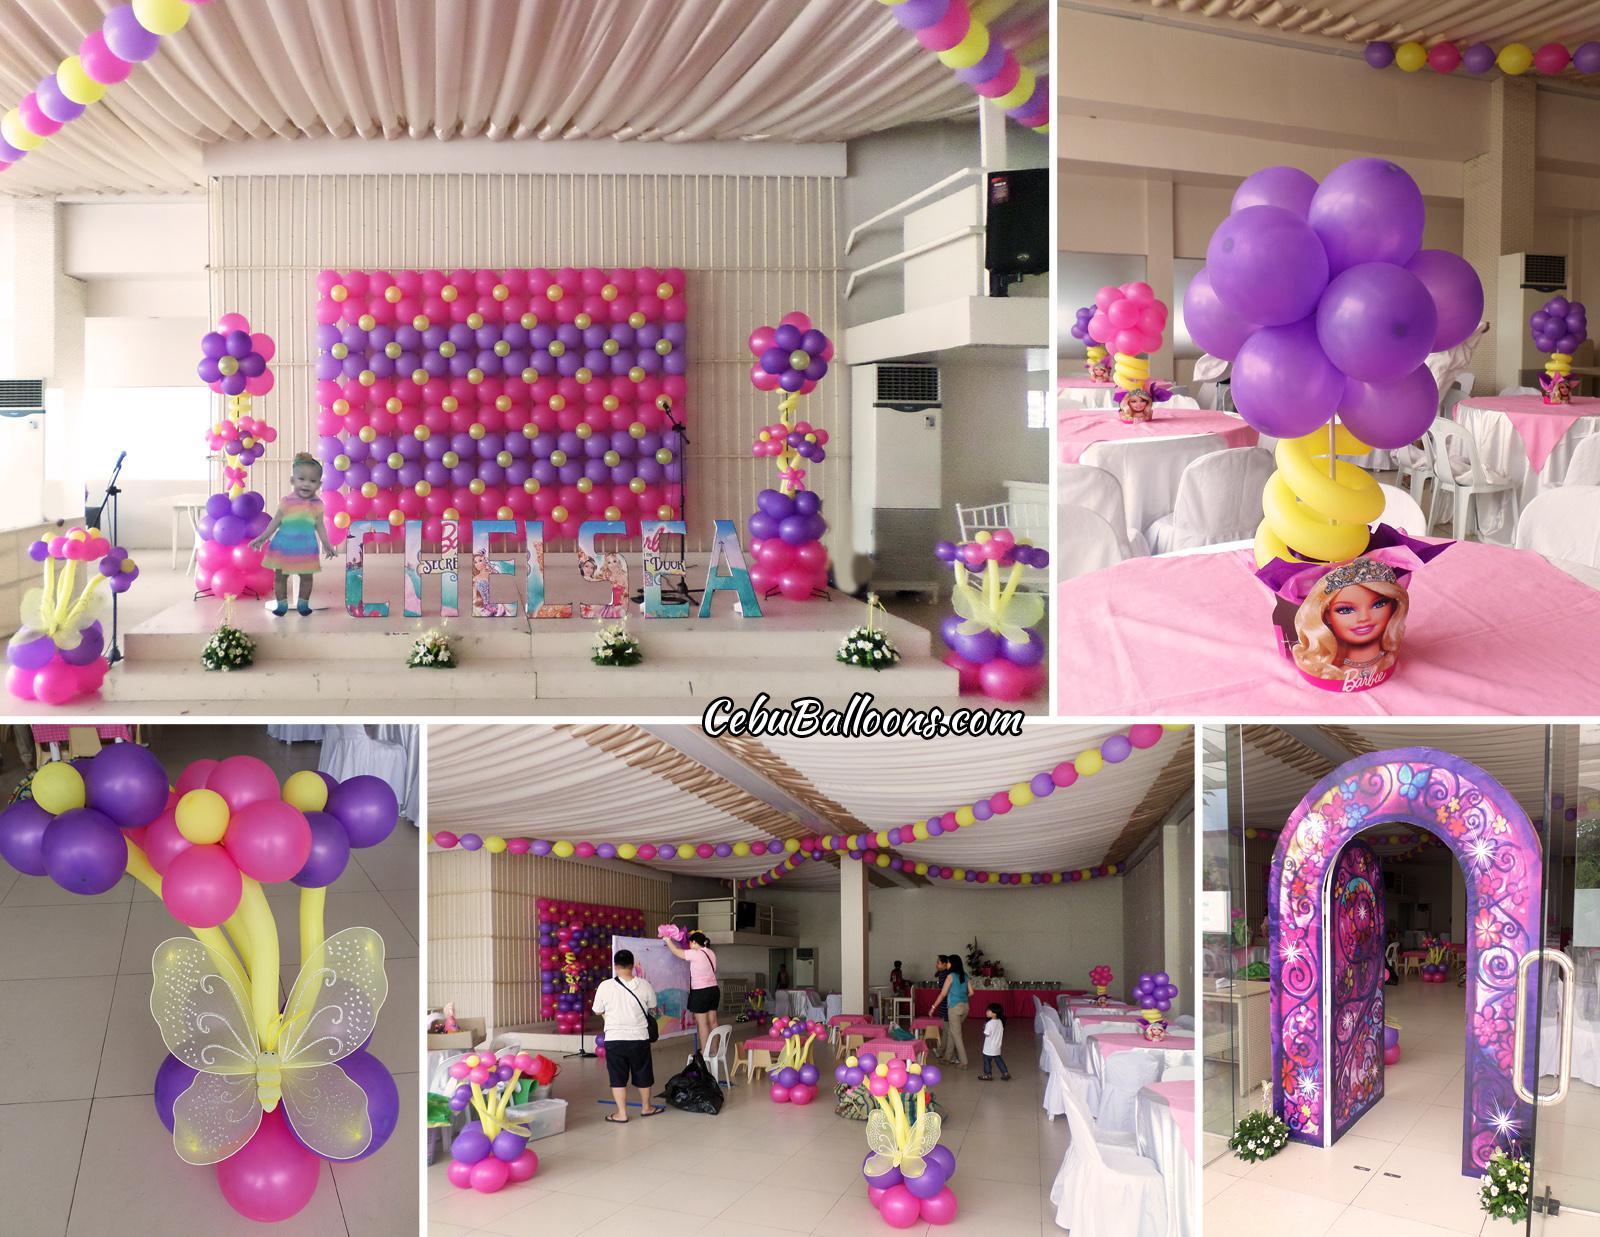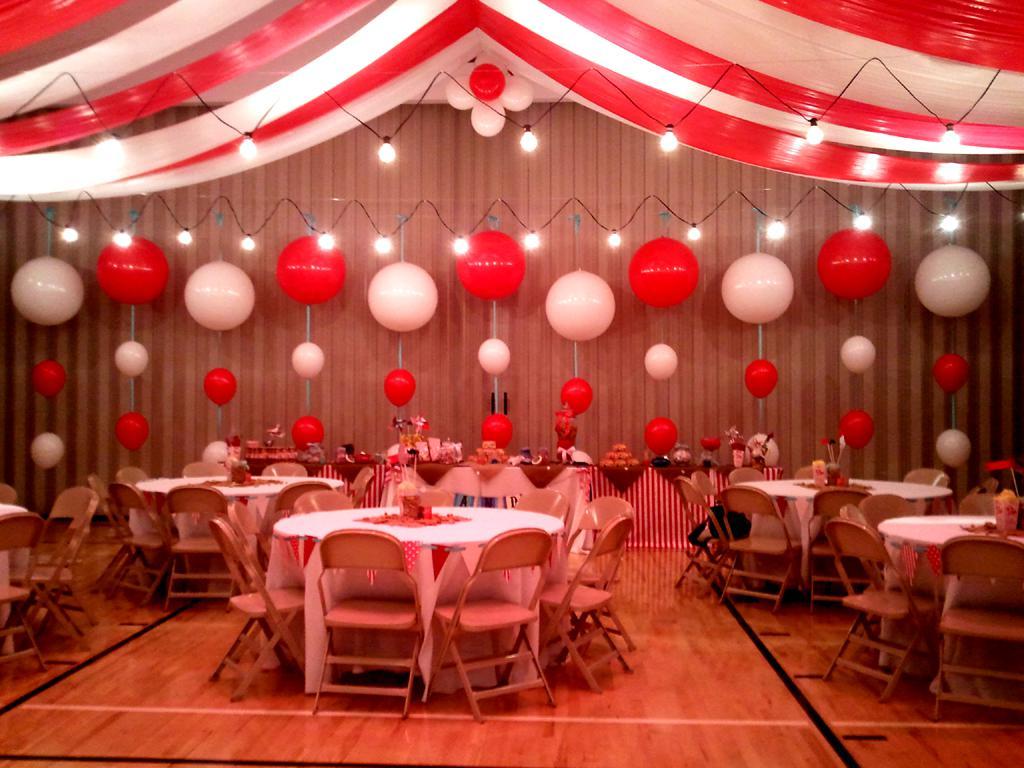The first image is the image on the left, the second image is the image on the right. Considering the images on both sides, is "In at least one image there is a balloon arch that is the same thickness all the way through with at least three rows of balloons.." valid? Answer yes or no. No. The first image is the image on the left, the second image is the image on the right. Evaluate the accuracy of this statement regarding the images: "An image shows a balloon arch that forms a semi-circle and includes white and reddish balloons.". Is it true? Answer yes or no. No. 